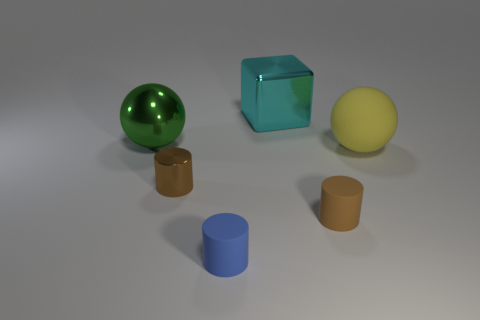Add 3 tiny matte things. How many objects exist? 9 Subtract all spheres. How many objects are left? 4 Subtract 0 purple spheres. How many objects are left? 6 Subtract all tiny rubber objects. Subtract all tiny yellow metallic spheres. How many objects are left? 4 Add 4 blue rubber things. How many blue rubber things are left? 5 Add 4 green metal blocks. How many green metal blocks exist? 4 